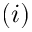<formula> <loc_0><loc_0><loc_500><loc_500>( i )</formula> 